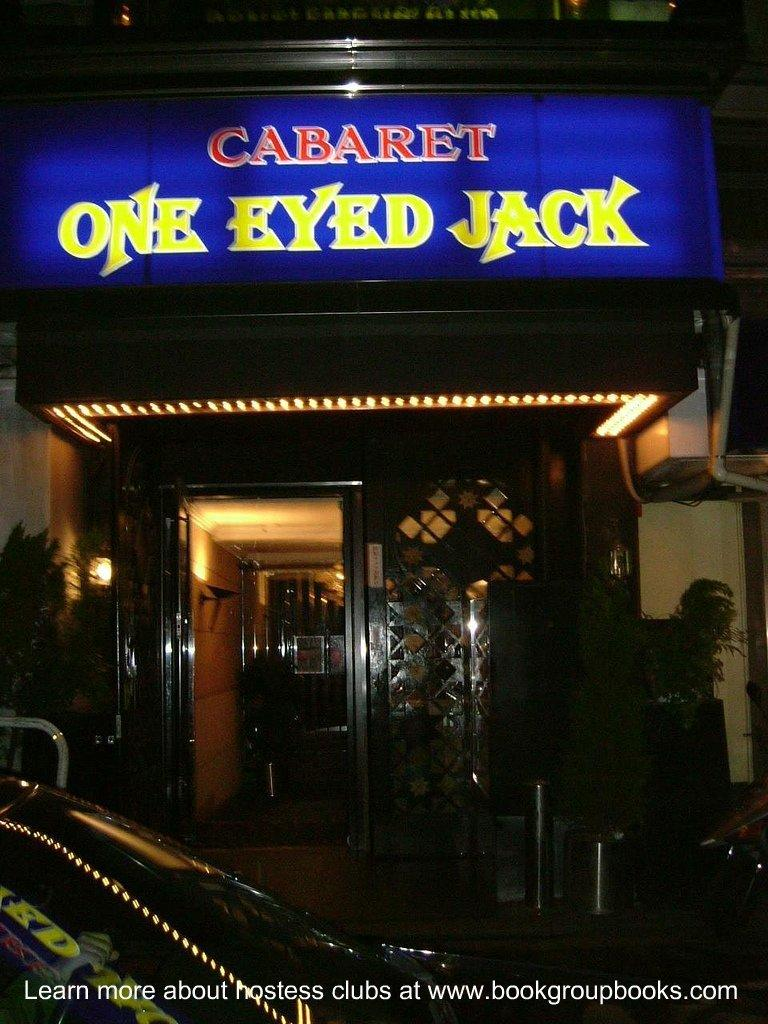What structure is located on the left side of the image? There is a door on the left side of the image. What type of vehicle is at the bottom side of the image? There is a car at the bottom side of the image. What is located at the top side of the image? There is a name board at the top side of the image. What type of reward is hanging from the car in the image? There is no reward present in the image, and the car is not associated with any reward. What unit is responsible for maintaining the door in the image? There is no specific unit mentioned in the image, and the door's maintenance is not the focus of the image. 